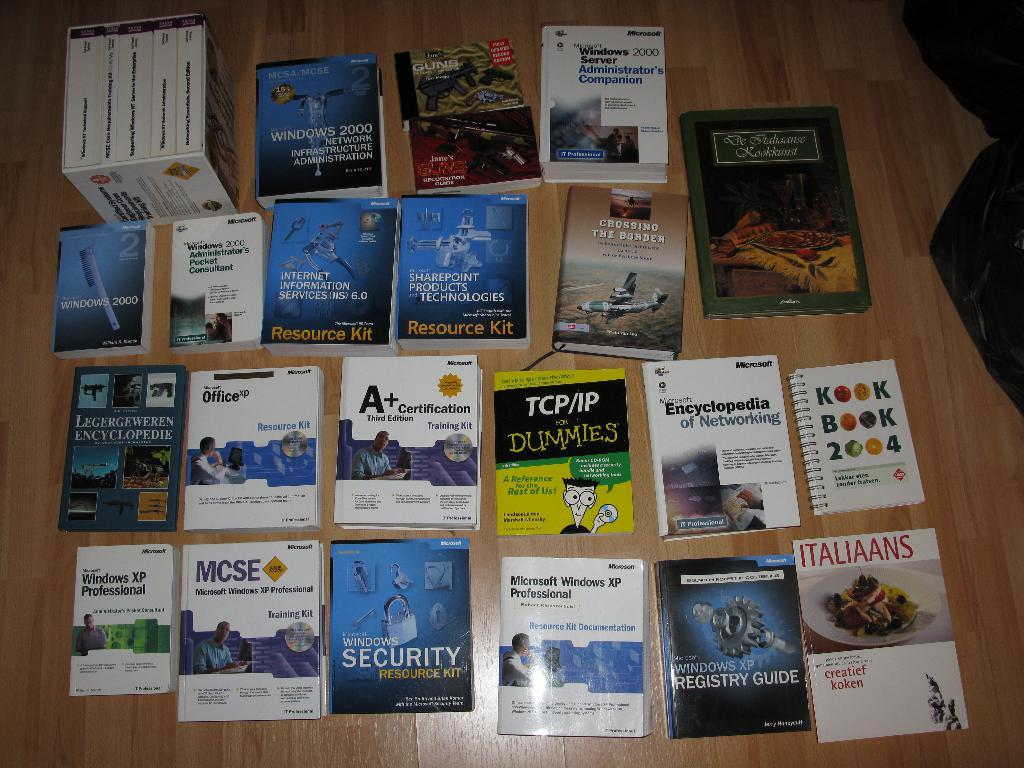<image>
Offer a succinct explanation of the picture presented. A bunch of books are spread out on a table including TCP/IP for Dummies. 